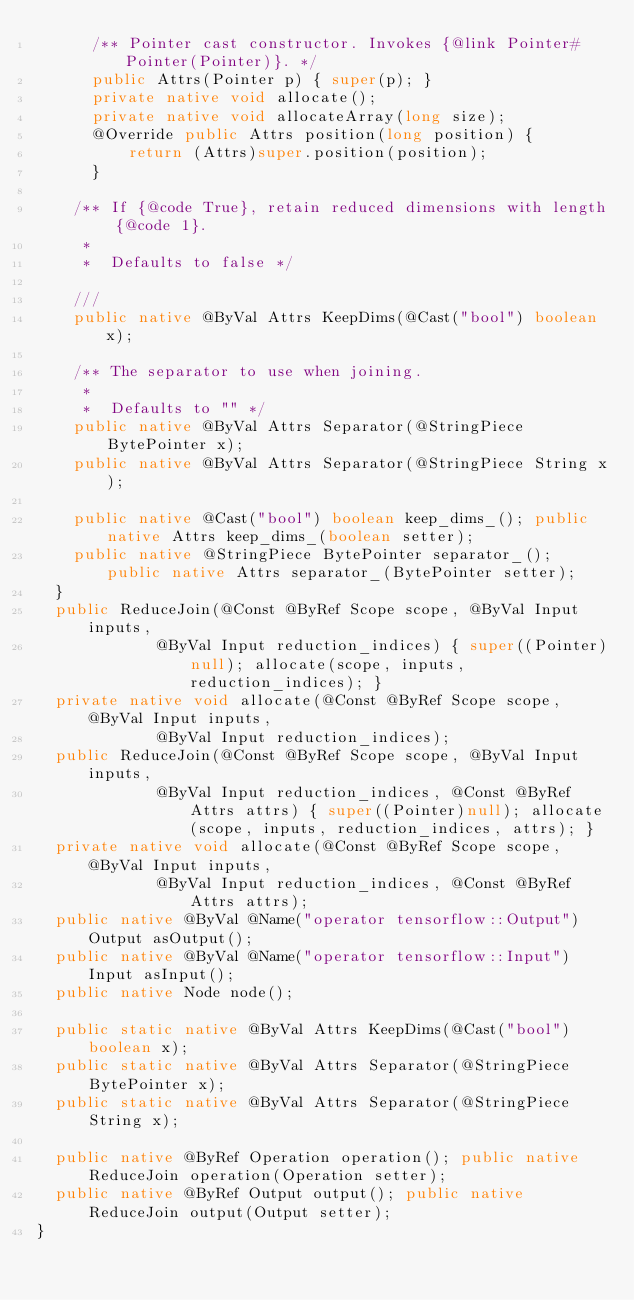Convert code to text. <code><loc_0><loc_0><loc_500><loc_500><_Java_>      /** Pointer cast constructor. Invokes {@link Pointer#Pointer(Pointer)}. */
      public Attrs(Pointer p) { super(p); }
      private native void allocate();
      private native void allocateArray(long size);
      @Override public Attrs position(long position) {
          return (Attrs)super.position(position);
      }
  
    /** If {@code True}, retain reduced dimensions with length {@code 1}.
     * 
     *  Defaults to false */
    
    ///
    public native @ByVal Attrs KeepDims(@Cast("bool") boolean x);

    /** The separator to use when joining.
     * 
     *  Defaults to "" */
    public native @ByVal Attrs Separator(@StringPiece BytePointer x);
    public native @ByVal Attrs Separator(@StringPiece String x);

    public native @Cast("bool") boolean keep_dims_(); public native Attrs keep_dims_(boolean setter);
    public native @StringPiece BytePointer separator_(); public native Attrs separator_(BytePointer setter);
  }
  public ReduceJoin(@Const @ByRef Scope scope, @ByVal Input inputs,
             @ByVal Input reduction_indices) { super((Pointer)null); allocate(scope, inputs, reduction_indices); }
  private native void allocate(@Const @ByRef Scope scope, @ByVal Input inputs,
             @ByVal Input reduction_indices);
  public ReduceJoin(@Const @ByRef Scope scope, @ByVal Input inputs,
             @ByVal Input reduction_indices, @Const @ByRef Attrs attrs) { super((Pointer)null); allocate(scope, inputs, reduction_indices, attrs); }
  private native void allocate(@Const @ByRef Scope scope, @ByVal Input inputs,
             @ByVal Input reduction_indices, @Const @ByRef Attrs attrs);
  public native @ByVal @Name("operator tensorflow::Output") Output asOutput();
  public native @ByVal @Name("operator tensorflow::Input") Input asInput();
  public native Node node();

  public static native @ByVal Attrs KeepDims(@Cast("bool") boolean x);
  public static native @ByVal Attrs Separator(@StringPiece BytePointer x);
  public static native @ByVal Attrs Separator(@StringPiece String x);

  public native @ByRef Operation operation(); public native ReduceJoin operation(Operation setter);
  public native @ByRef Output output(); public native ReduceJoin output(Output setter);
}
</code> 